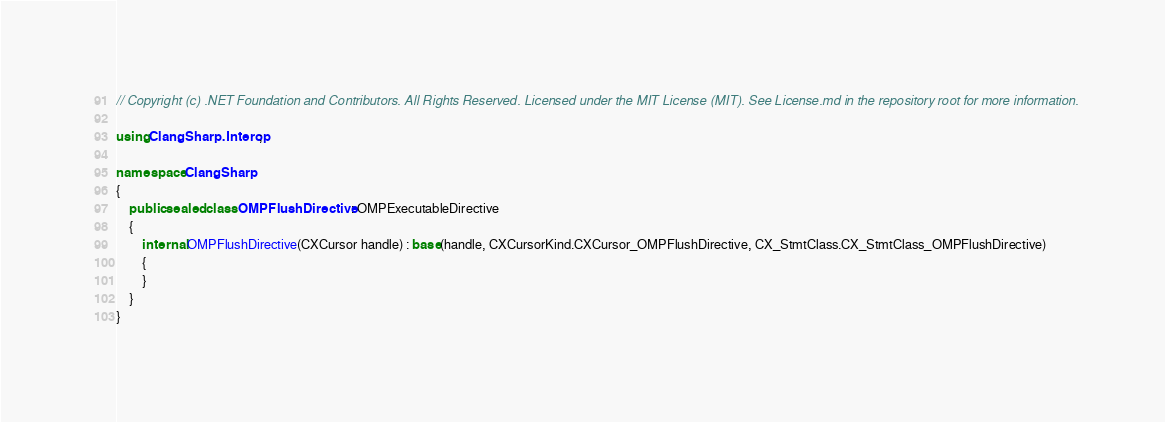<code> <loc_0><loc_0><loc_500><loc_500><_C#_>// Copyright (c) .NET Foundation and Contributors. All Rights Reserved. Licensed under the MIT License (MIT). See License.md in the repository root for more information.

using ClangSharp.Interop;

namespace ClangSharp
{
    public sealed class OMPFlushDirective : OMPExecutableDirective
    {
        internal OMPFlushDirective(CXCursor handle) : base(handle, CXCursorKind.CXCursor_OMPFlushDirective, CX_StmtClass.CX_StmtClass_OMPFlushDirective)
        {
        }
    }
}
</code> 